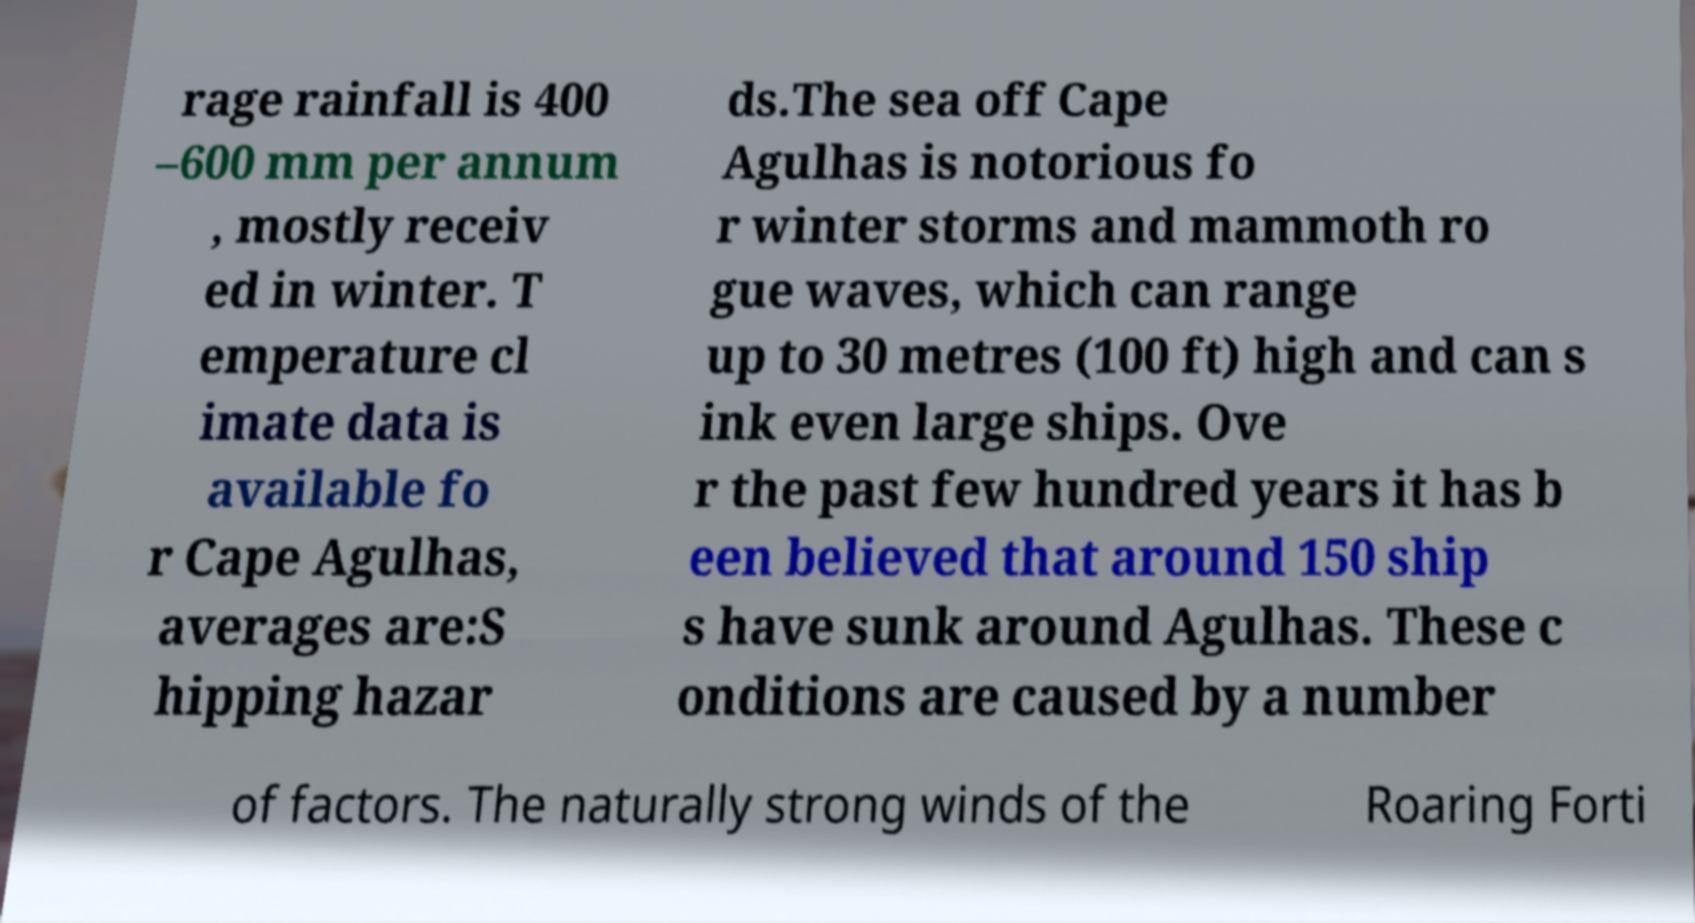I need the written content from this picture converted into text. Can you do that? rage rainfall is 400 –600 mm per annum , mostly receiv ed in winter. T emperature cl imate data is available fo r Cape Agulhas, averages are:S hipping hazar ds.The sea off Cape Agulhas is notorious fo r winter storms and mammoth ro gue waves, which can range up to 30 metres (100 ft) high and can s ink even large ships. Ove r the past few hundred years it has b een believed that around 150 ship s have sunk around Agulhas. These c onditions are caused by a number of factors. The naturally strong winds of the Roaring Forti 